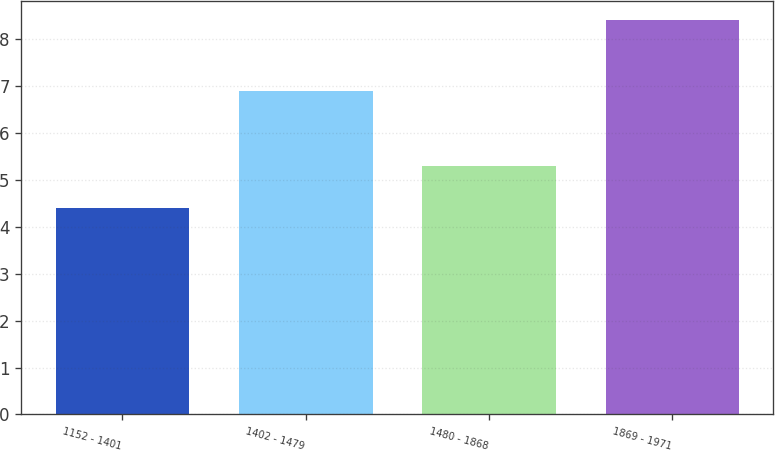Convert chart. <chart><loc_0><loc_0><loc_500><loc_500><bar_chart><fcel>1152 - 1401<fcel>1402 - 1479<fcel>1480 - 1868<fcel>1869 - 1971<nl><fcel>4.4<fcel>6.9<fcel>5.3<fcel>8.4<nl></chart> 